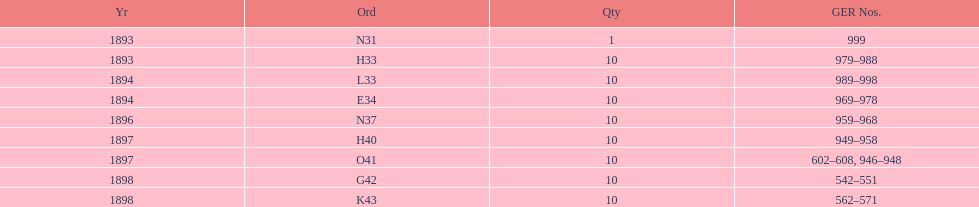What length of time is covered by the years? 5 years. Can you give me this table as a dict? {'header': ['Yr', 'Ord', 'Qty', 'GER Nos.'], 'rows': [['1893', 'N31', '1', '999'], ['1893', 'H33', '10', '979–988'], ['1894', 'L33', '10', '989–998'], ['1894', 'E34', '10', '969–978'], ['1896', 'N37', '10', '959–968'], ['1897', 'H40', '10', '949–958'], ['1897', 'O41', '10', '602–608, 946–948'], ['1898', 'G42', '10', '542–551'], ['1898', 'K43', '10', '562–571']]} 